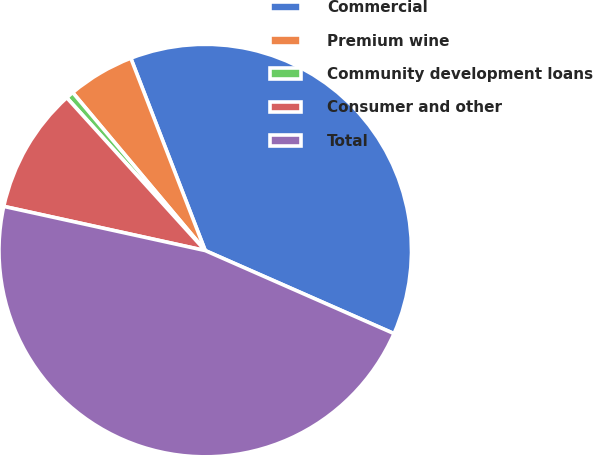<chart> <loc_0><loc_0><loc_500><loc_500><pie_chart><fcel>Commercial<fcel>Premium wine<fcel>Community development loans<fcel>Consumer and other<fcel>Total<nl><fcel>37.47%<fcel>5.23%<fcel>0.61%<fcel>9.85%<fcel>46.84%<nl></chart> 